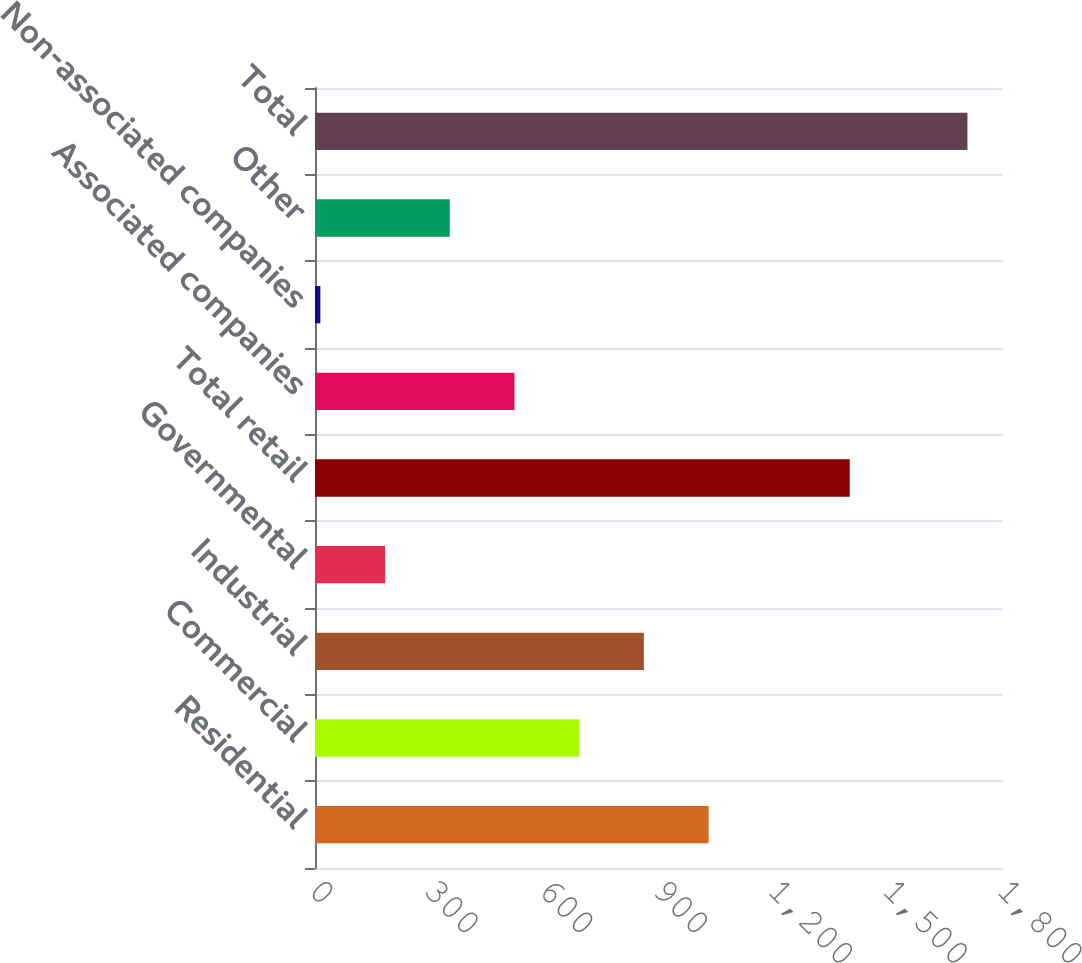Convert chart. <chart><loc_0><loc_0><loc_500><loc_500><bar_chart><fcel>Residential<fcel>Commercial<fcel>Industrial<fcel>Governmental<fcel>Total retail<fcel>Associated companies<fcel>Non-associated companies<fcel>Other<fcel>Total<nl><fcel>1029.8<fcel>691.2<fcel>860.5<fcel>183.3<fcel>1399<fcel>521.9<fcel>14<fcel>352.6<fcel>1707<nl></chart> 